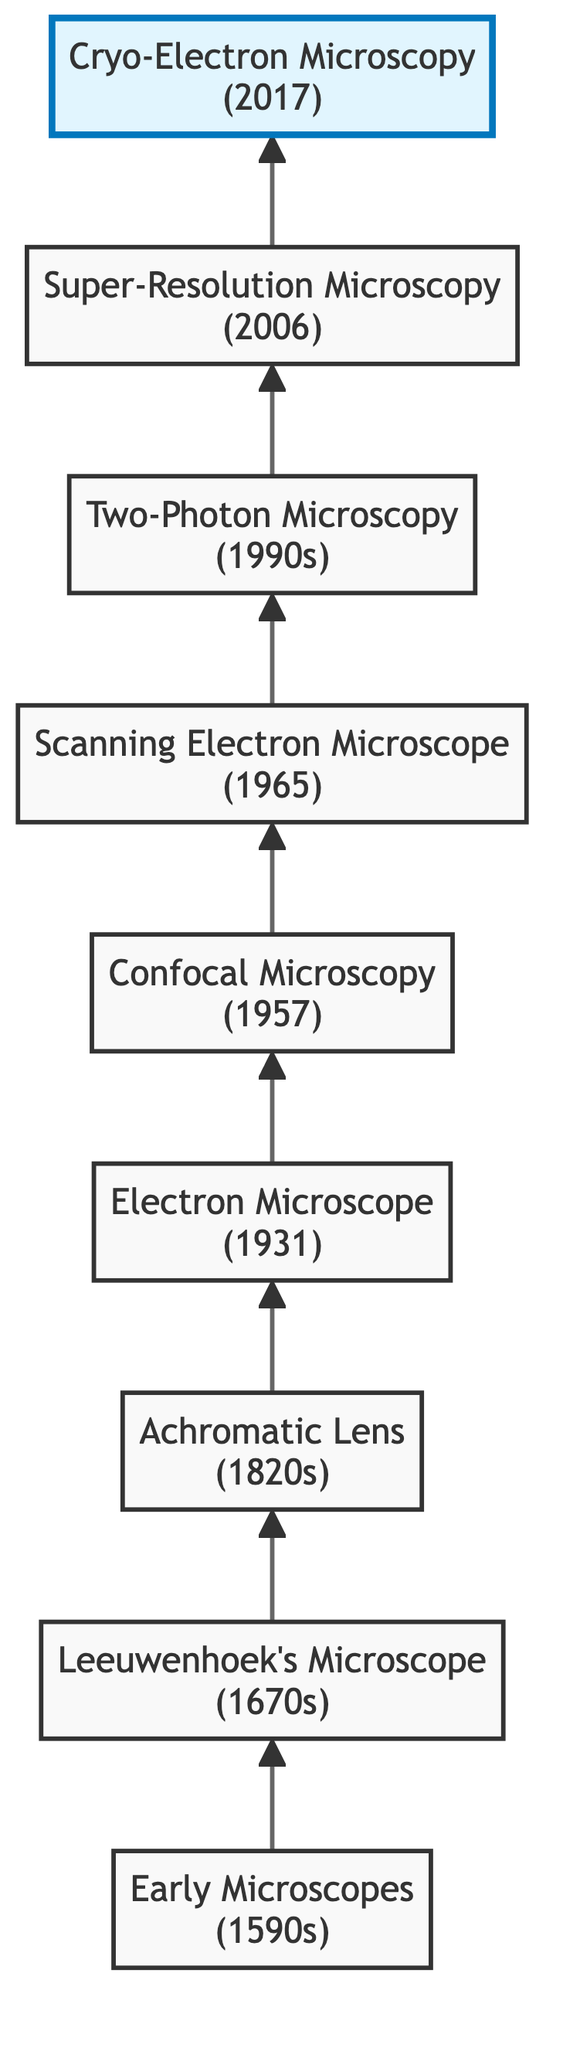What is the earliest device in the diagram? The diagram shows "Early Microscopes" at the bottom. This is the first element listed in the flow chart, representing the starting point of bio-imaging equipment evolution.
Answer: Early Microscopes Which device follows Leeuwenhoek’s Microscope in the diagram? After Leeuwenhoek's Microscope, the next device listed in the flow chart is the "Achromatic Lens". According to the flow order, it is positioned directly above Leeuwenhoek's Microscope.
Answer: Achromatic Lens What decade did the Electron Microscope emerge? The Electron Microscope is indicated in the diagram with the year "1931". This clearly shows the decade of the 1930s when this device was developed.
Answer: 1930s How many devices are there in total in the diagram? By counting the listed devices in the flow chart, we find a total of 9 distinct elements from "Early Microscopes" to "Cryo-Electron Microscopy". This count provides a full view of the historical evolution presented.
Answer: 9 What type of microscopy did Marvin Minsky invent? The diagram specifies that Marvin Minsky invented "Confocal Microscopy" in 1957. This detail is explicitly included, highlighting his contribution to the field of bio-imaging.
Answer: Confocal Microscopy Which imaging technique allows for deeper tissue imaging without photodamage? The diagram indicates "Two-Photon Microscopy" as the technique developed for deeper tissue imaging while minimizing photodamage. This information can be directly read from its description in the flow chart.
Answer: Two-Photon Microscopy What is the latest advancement listed in the diagram? The "Cryo-Electron Microscopy" is the last entry in the flow, labeled with the year 2017. This indicates it is the most recent advancement in bio-imaging equipment depicted in the diagram.
Answer: Cryo-Electron Microscopy Explain the improvement associated with "Achromatic Lens". The description states that Joseph Jackson Lister improved image clarity by reducing chromatic aberration with achromatic lenses, leading to better imaging outcomes. This is established as a significant evolutionary improvement in microscopy.
Answer: Improved image clarity How does "Scanning Electron Microscope" relate to "Electron Microscope"? The flowchart shows that the "Scanning Electron Microscope" is developed after the "Electron Microscope," indicating that SEM is a subsequent advancement that builds on the foundational technology provided by the earlier electron microscope.
Answer: SEM follows Electron Microscope 